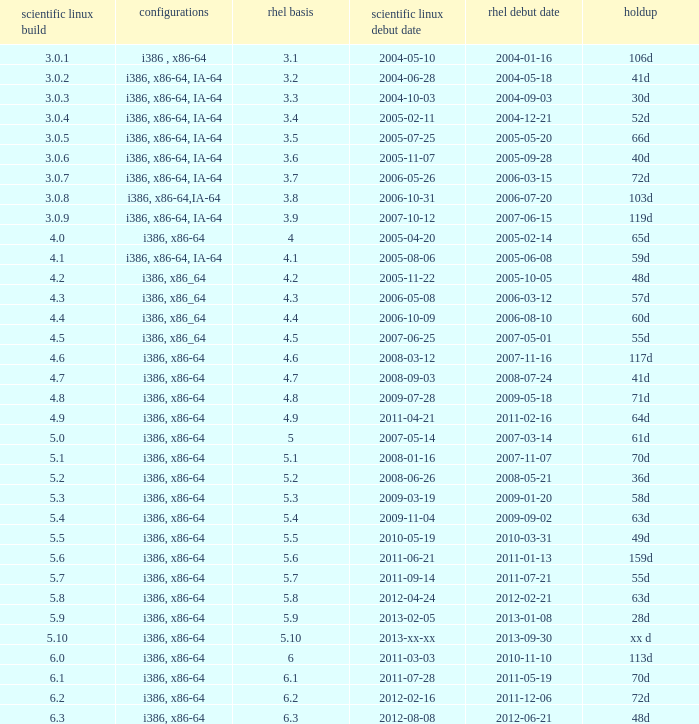When is the rhel release date when scientific linux release is 3.0.4 2004-12-21. 